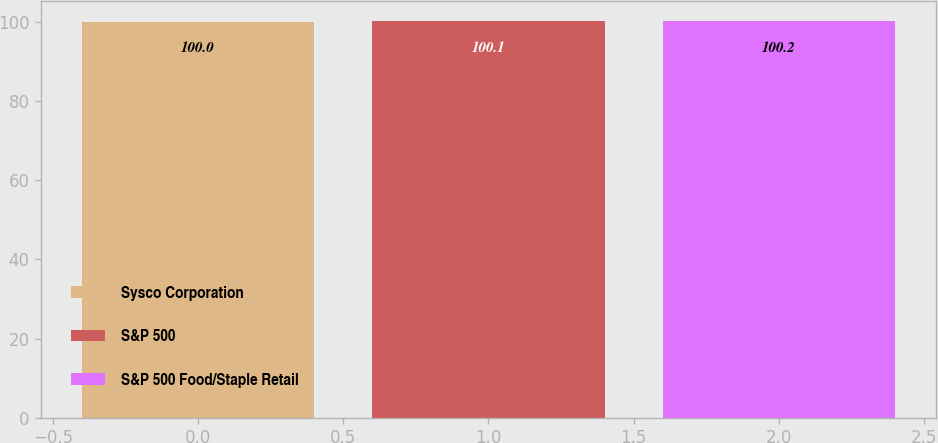<chart> <loc_0><loc_0><loc_500><loc_500><bar_chart><fcel>Sysco Corporation<fcel>S&P 500<fcel>S&P 500 Food/Staple Retail<nl><fcel>100<fcel>100.1<fcel>100.2<nl></chart> 